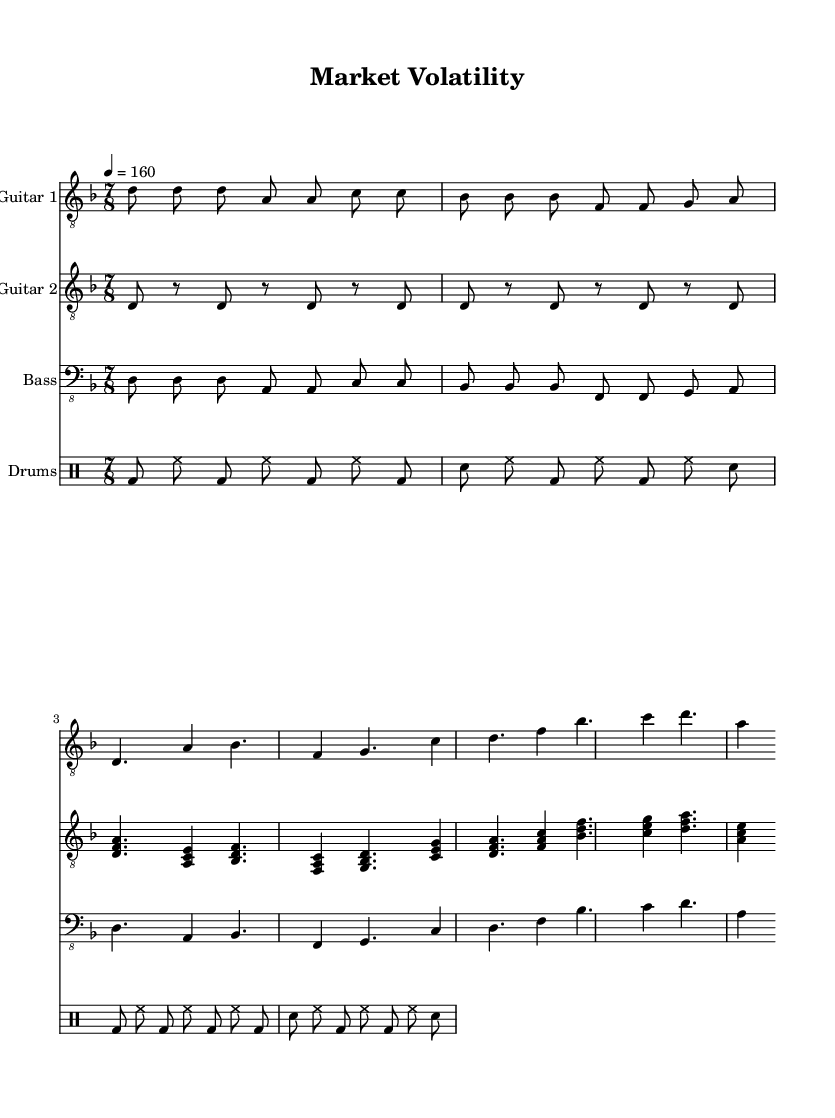What is the key signature of this music? The key signature indicated in the global block is D minor, which typically includes one flat (B♭).
Answer: D minor What is the time signature of the piece? The time signature specified in the global block is 7/8, which means there are seven beats in each measure and the eighth note gets the beat.
Answer: 7/8 What tempo marking is provided? The tempo marking in the global section indicates a speed of 160 beats per minute, which gives a brisk and energetic feel typical of metal music.
Answer: 160 Describe the number of instruments used in this score. There are four distinct staves indicating four different instruments: Guitar 1, Guitar 2, Bass, and Drums. This is a typical setup for a progressive metal band.
Answer: Four How does the main riff relate to the verse progression? The main riff, which appears at the beginning, is repeated several times and then transitions to the verse progression, showcasing the complexity typical of progressive metal by alternating between established themes and varying structures. The repetition helps to build the musical narrative.
Answer: Repetition and transition What are the primary chords used during the chorus? The chorus progression consists of the following primary chords: D minor, F major, B♭ major, and C major. These chords create a contrasting sound, enhancing the emotional impact typical in metal music.
Answer: D minor, F major, B♭ major, C major Identify the type of rhythm used in the drums section. The drum rhythms provided consist of a combination of bass and snare hits, alongside hi-hat patterns, which are characteristic of driving metal drumming, providing a strong backbone for the other instruments.
Answer: Bass and snare hits with hi-hat patterns 